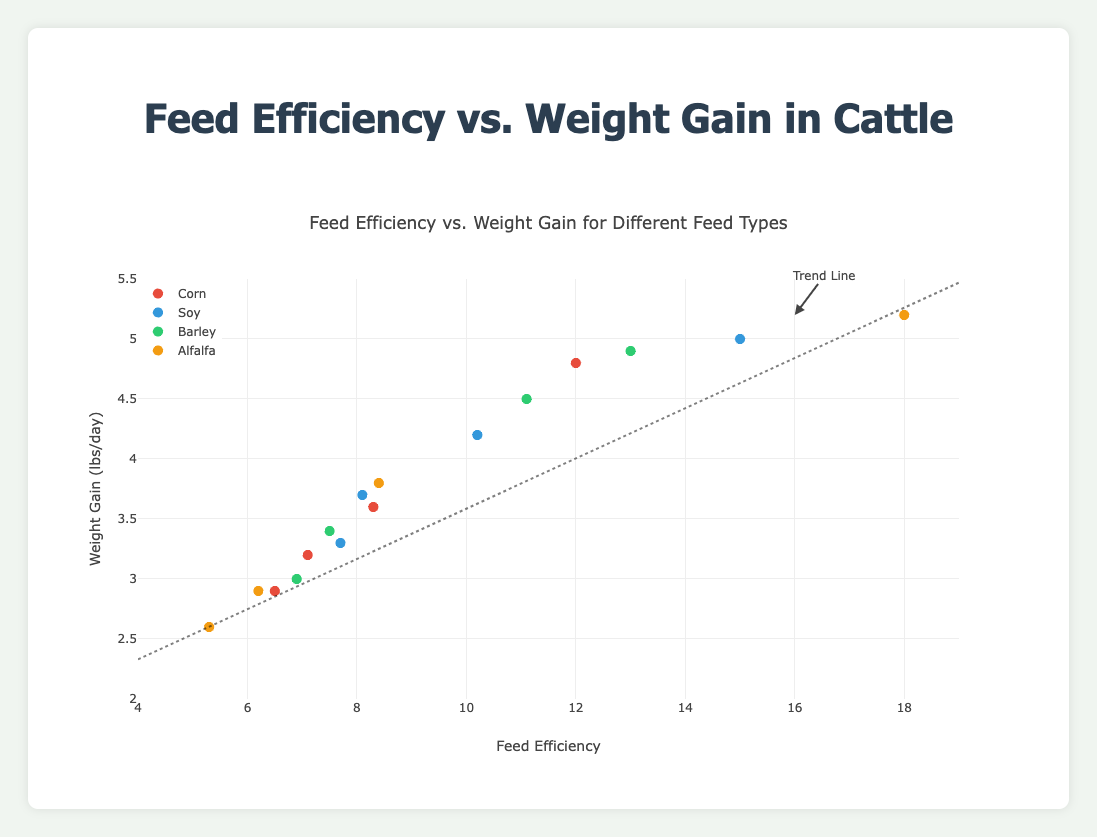What is the title of the figure? The title is located at the top of the figure. It describes what the plot represents.
Answer: Feed Efficiency vs. Weight Gain for Different Feed Types How many different feed types are represented in the figure? The legend on the right side of the figure lists the different feed types.
Answer: 4 What color represents the Corn feed type on the plot? By referring to the legend, it shows the color associated with Corn.
Answer: Red Which feed type has the highest Feed Efficiency value? By looking at the x-axis (Feed Efficiency) and identifying the highest value among the points, then cross-referencing with the legend.
Answer: Alfalfa (18.0) What is the range of the Weight Gain axis? The y-axis indicates the range of Weight Gain values on the figure.
Answer: 2 to 5.5 lbs/day What does the dotted line in the figure represent? The dotted line is labeled with an annotation that explains its purpose.
Answer: Trend Line Which feed type has multiple outliers based on Feed Efficiency, and what are those values? Outliers are easily spotted as points that are far from the general cluster of points for each feed type. Alfalfa has the highest spread in Feed Efficiency.
Answer: Alfalfa, with outliers around 18.0 Which feed type achieves the highest weight gain and what is its value in lbs/day? By looking at the y-axis (Weight Gain) and identifying the highest value among the points, then cross-referencing with the legend.
Answer: Alfalfa, 5.2 lbs/day What is the average Weight Gain for Barley feed type? Identify all Weight Gain values for Barley from the plot: 3.0, 3.4, 4.5, 4.9. Sum these values and divide by the number of points.
Answer: (3.0 + 3.4 + 4.5 + 4.9) / 4 = 3.95 lbs/day Which feed type shows the steepest trend in Weight Gain as Feed Efficiency increases? Examine the slope of the points or check the steepness visually. Lines with steeper slopes indicate a stronger effect of Feed Efficiency on Weight Gain.
Answer: Soy 